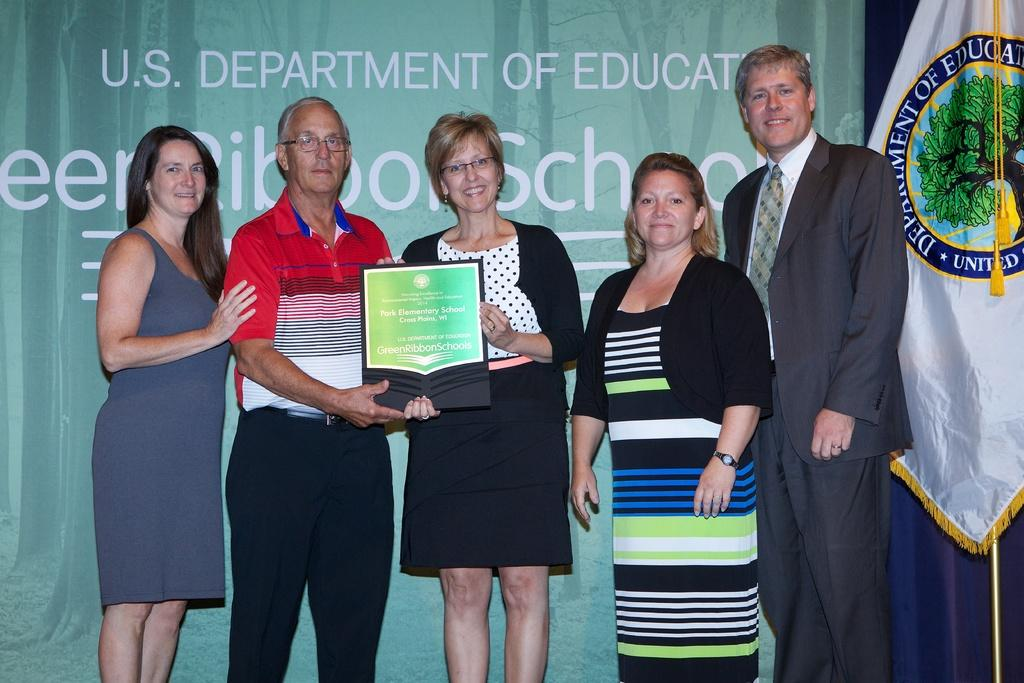What are the people in the image doing? There are people standing in the image. Can you describe what the two people holding a frame are doing? Two people are holding a frame in the image. What can be seen in the image besides the people and the frame? There is a flag visible in the image. What is present in the background of the image? There is a banner in the background of the image. What type of bone is being used to hold the frame in the image? There is no bone present in the image; the two people are holding the frame with their hands. 